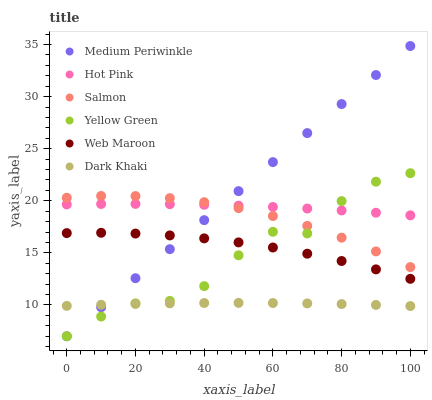Does Dark Khaki have the minimum area under the curve?
Answer yes or no. Yes. Does Medium Periwinkle have the maximum area under the curve?
Answer yes or no. Yes. Does Hot Pink have the minimum area under the curve?
Answer yes or no. No. Does Hot Pink have the maximum area under the curve?
Answer yes or no. No. Is Medium Periwinkle the smoothest?
Answer yes or no. Yes. Is Yellow Green the roughest?
Answer yes or no. Yes. Is Hot Pink the smoothest?
Answer yes or no. No. Is Hot Pink the roughest?
Answer yes or no. No. Does Yellow Green have the lowest value?
Answer yes or no. Yes. Does Hot Pink have the lowest value?
Answer yes or no. No. Does Medium Periwinkle have the highest value?
Answer yes or no. Yes. Does Hot Pink have the highest value?
Answer yes or no. No. Is Dark Khaki less than Web Maroon?
Answer yes or no. Yes. Is Salmon greater than Web Maroon?
Answer yes or no. Yes. Does Medium Periwinkle intersect Dark Khaki?
Answer yes or no. Yes. Is Medium Periwinkle less than Dark Khaki?
Answer yes or no. No. Is Medium Periwinkle greater than Dark Khaki?
Answer yes or no. No. Does Dark Khaki intersect Web Maroon?
Answer yes or no. No. 